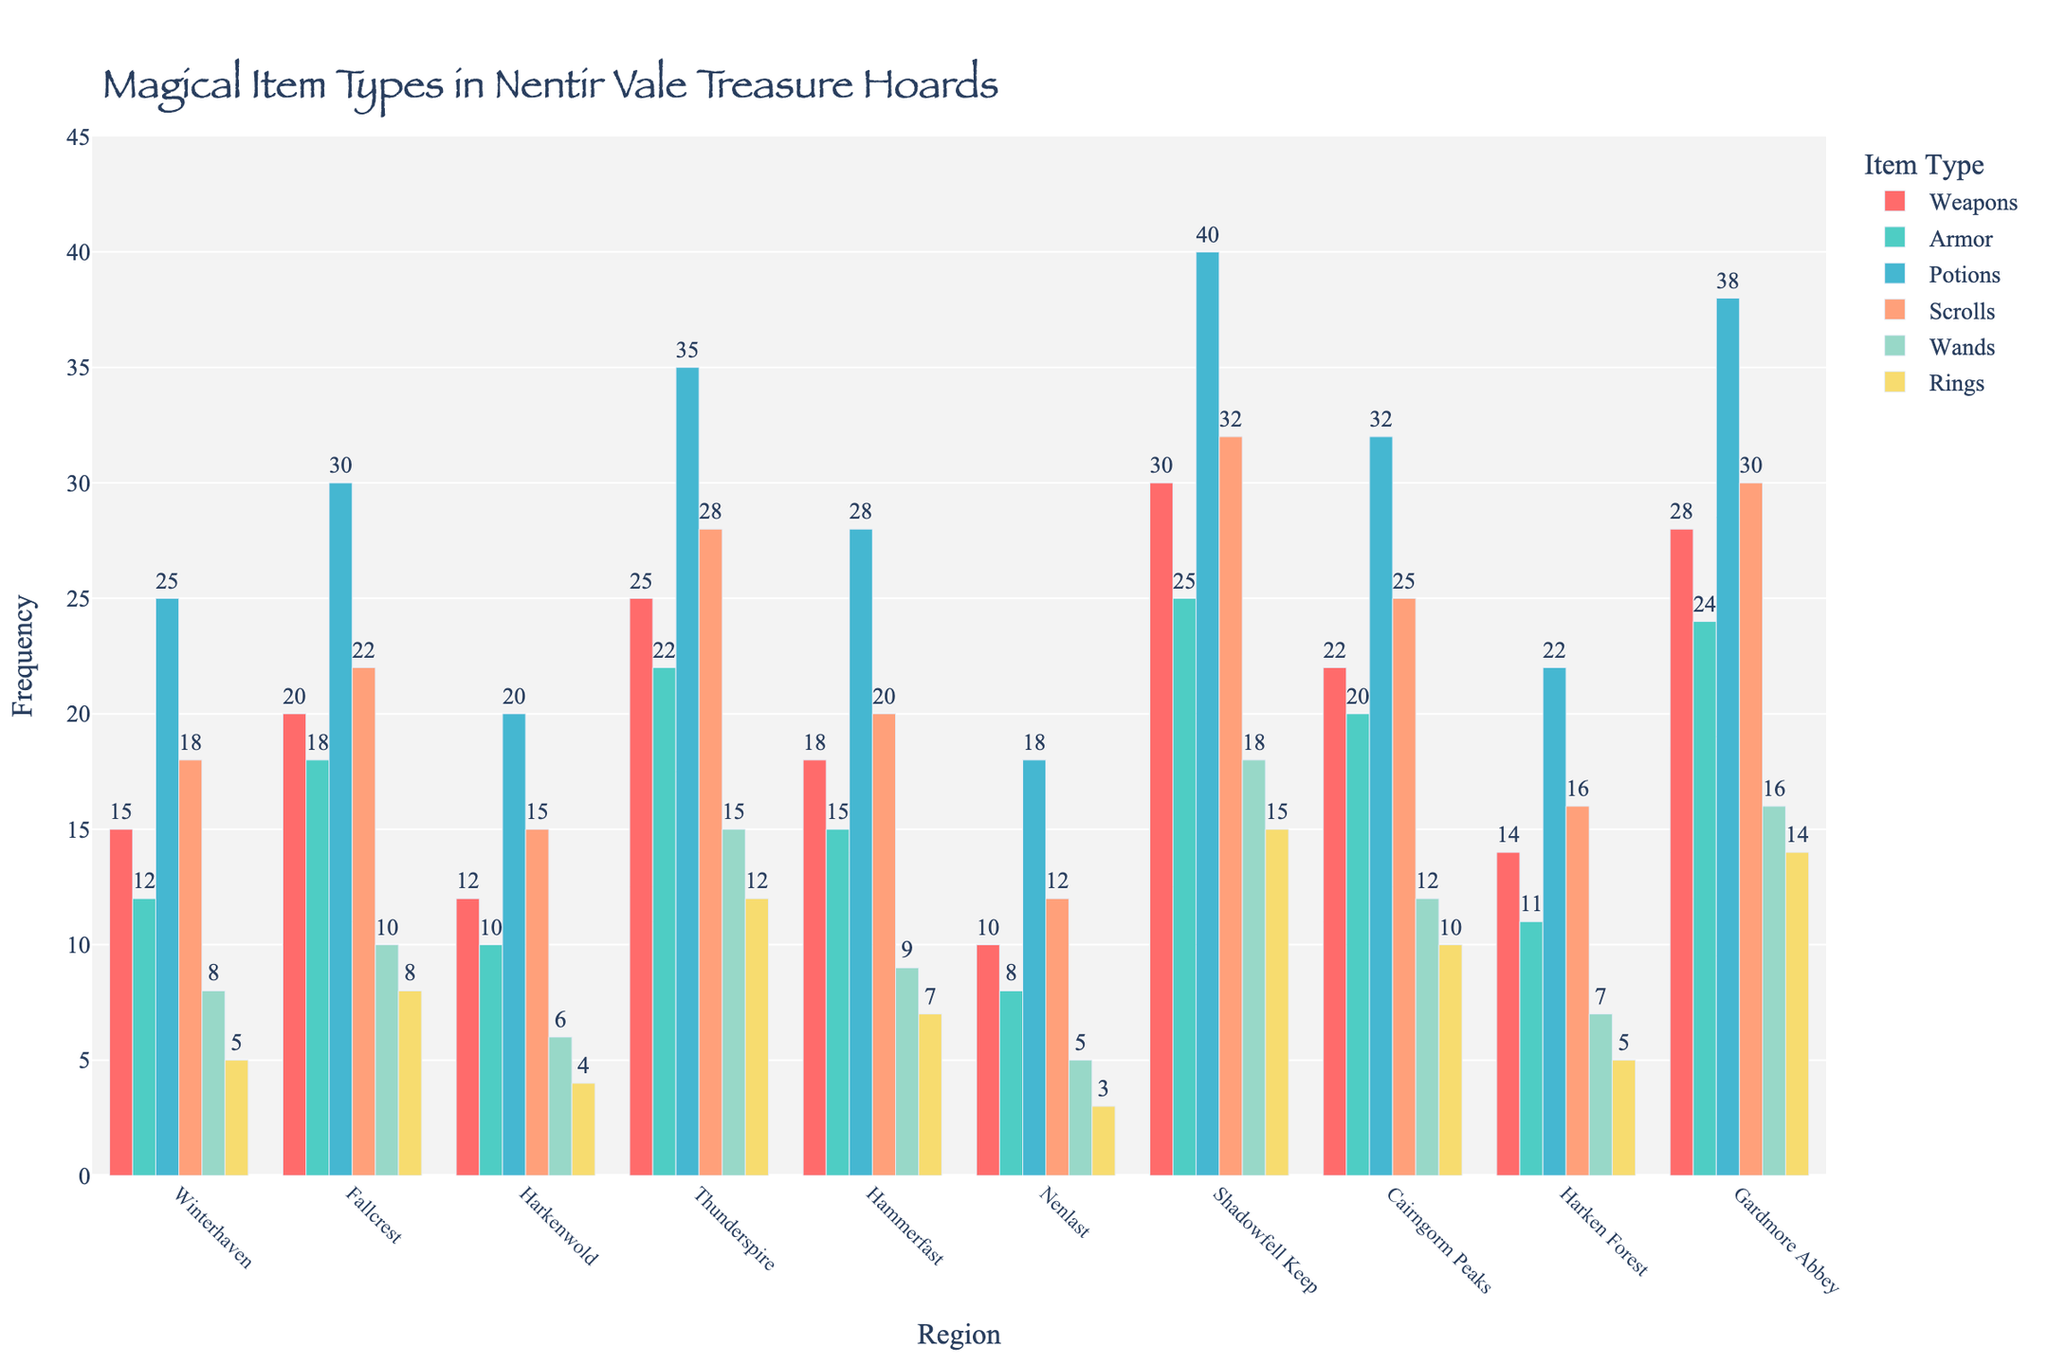What's the most frequently found magical item type in Gardmore Abbey? Look for Gardmore Abbey in the chart and identify the highest bar among the item types associated with this region. The 'Scrolls' bar appears to be the highest.
Answer: Scrolls By how much do the scrolls found in Winterhaven exceed those found in Nenlast? Locate the scrolls count for Winterhaven and Nenlast. The frequency for Winterhaven is 18, and for Nenlast, it's 12. The difference is calculated as 18 - 12.
Answer: 6 Which region has the lowest frequency of wands? Compare the height of the bars representing wands across all regions. Nenlast, with a value of 5, has the shortest bar for wands.
Answer: Nenlast What is the average frequency of potions found in Fallcrest, Thunderspire, and Hammerfast? To calculate the average frequency, sum the values of potions in these regions (30 in Fallcrest, 35 in Thunderspire, and 28 in Hammerfast) and divide by the number of regions, which is 3. The average is (30 + 35 + 28) / 3.
Answer: 31 How many more rings are found in Shadowfell Keep compared to Harkenwold? Identify the number of rings in Shadowfell Keep and Harkenwold. The frequency for rings in Shadowfell Keep is 15, and in Harkenwold, it's 4. Calculate the difference: 15 - 4.
Answer: 11 What is the total number of armor items found in Thunderspire and Harken Forest? Sum the number of armor pieces found in both Thunderspire and Harken Forest. Thunderspire has 22, and Harken Forest has 11. The total is 22 + 11.
Answer: 33 What is the most common magical item type across all regions? Check the bars for each item type across all regions to determine which type has the consistently highest values. 'Scrolls' appear to be the most common.
Answer: Scrolls Between Weapons in Fallcrest and Armor in Gardmore Abbey, which has the higher frequency? Compare the bar for weapons in Fallcrest with the bar for armor in Gardmore Abbey. Weapons in Fallcrest have a frequency of 20, while armor in Gardmore Abbey has a frequency of 24.
Answer: Armor in Gardmore Abbey Which region has the most balanced distribution of magical items? Look for the region with bars of similar height across all item types. Harkenwold appears to have more evenly distributed frequencies across different item types.
Answer: Harkenwold 